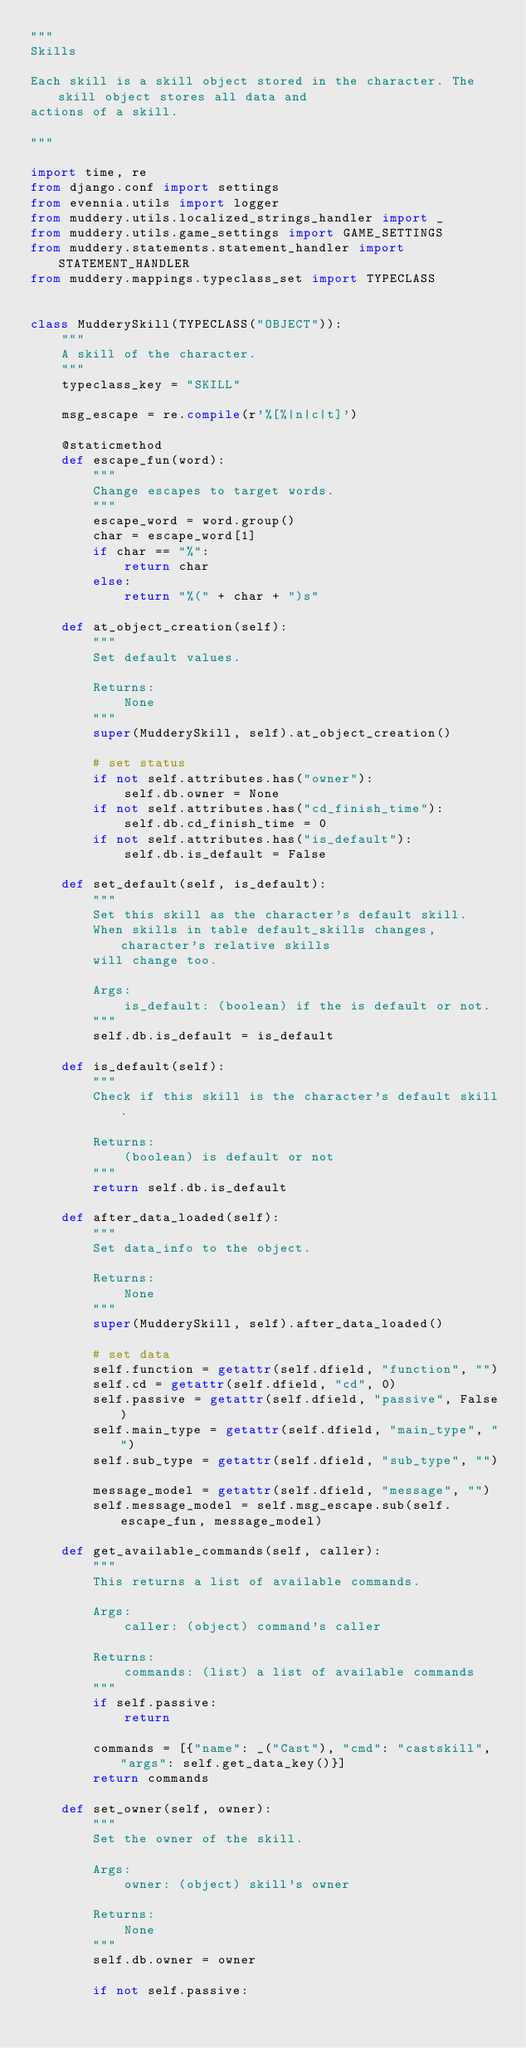<code> <loc_0><loc_0><loc_500><loc_500><_Python_>"""
Skills

Each skill is a skill object stored in the character. The skill object stores all data and
actions of a skill.

"""

import time, re
from django.conf import settings
from evennia.utils import logger
from muddery.utils.localized_strings_handler import _
from muddery.utils.game_settings import GAME_SETTINGS
from muddery.statements.statement_handler import STATEMENT_HANDLER
from muddery.mappings.typeclass_set import TYPECLASS


class MudderySkill(TYPECLASS("OBJECT")):
    """
    A skill of the character.
    """
    typeclass_key = "SKILL"

    msg_escape = re.compile(r'%[%|n|c|t]')

    @staticmethod
    def escape_fun(word):
        """
        Change escapes to target words.
        """
        escape_word = word.group()
        char = escape_word[1]
        if char == "%":
            return char
        else:
            return "%(" + char + ")s"

    def at_object_creation(self):
        """
        Set default values.

        Returns:
            None
        """
        super(MudderySkill, self).at_object_creation()
        
        # set status
        if not self.attributes.has("owner"):
            self.db.owner = None
        if not self.attributes.has("cd_finish_time"):
            self.db.cd_finish_time = 0
        if not self.attributes.has("is_default"):
            self.db.is_default = False

    def set_default(self, is_default):
        """
        Set this skill as the character's default skill.
        When skills in table default_skills changes, character's relative skills
        will change too.

        Args:
            is_default: (boolean) if the is default or not.
        """
        self.db.is_default = is_default

    def is_default(self):
        """
        Check if this skill is the character's default skill.

        Returns:
            (boolean) is default or not
        """
        return self.db.is_default

    def after_data_loaded(self):
        """
        Set data_info to the object.

        Returns:
            None
        """
        super(MudderySkill, self).after_data_loaded()

        # set data
        self.function = getattr(self.dfield, "function", "")
        self.cd = getattr(self.dfield, "cd", 0)
        self.passive = getattr(self.dfield, "passive", False)
        self.main_type = getattr(self.dfield, "main_type", "")
        self.sub_type = getattr(self.dfield, "sub_type", "")
        
        message_model = getattr(self.dfield, "message", "")
        self.message_model = self.msg_escape.sub(self.escape_fun, message_model)

    def get_available_commands(self, caller):
        """
        This returns a list of available commands.

        Args:
            caller: (object) command's caller

        Returns:
            commands: (list) a list of available commands
        """
        if self.passive:
            return

        commands = [{"name": _("Cast"), "cmd": "castskill", "args": self.get_data_key()}]
        return commands

    def set_owner(self, owner):
        """
        Set the owner of the skill.

        Args:
            owner: (object) skill's owner

        Returns:
            None
        """
        self.db.owner = owner
    
        if not self.passive:</code> 